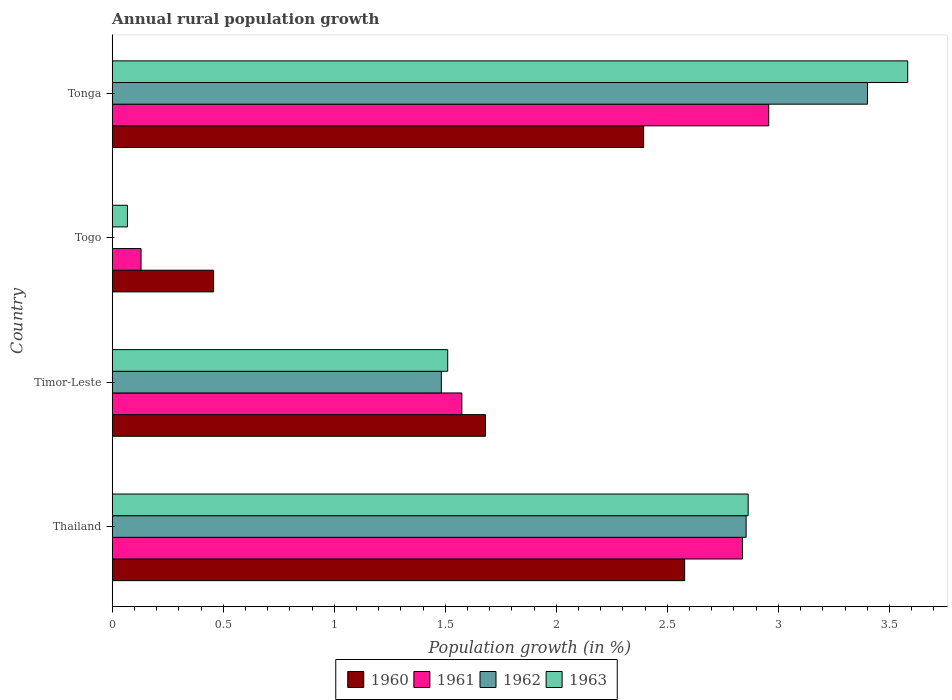How many groups of bars are there?
Your response must be concise. 4. Are the number of bars per tick equal to the number of legend labels?
Give a very brief answer. No. How many bars are there on the 3rd tick from the bottom?
Your answer should be very brief. 3. What is the label of the 4th group of bars from the top?
Keep it short and to the point. Thailand. In how many cases, is the number of bars for a given country not equal to the number of legend labels?
Make the answer very short. 1. What is the percentage of rural population growth in 1961 in Tonga?
Provide a short and direct response. 2.96. Across all countries, what is the maximum percentage of rural population growth in 1960?
Your answer should be compact. 2.58. Across all countries, what is the minimum percentage of rural population growth in 1962?
Give a very brief answer. 0. In which country was the percentage of rural population growth in 1961 maximum?
Provide a short and direct response. Tonga. What is the total percentage of rural population growth in 1961 in the graph?
Ensure brevity in your answer.  7.5. What is the difference between the percentage of rural population growth in 1960 in Thailand and that in Togo?
Keep it short and to the point. 2.12. What is the difference between the percentage of rural population growth in 1961 in Togo and the percentage of rural population growth in 1960 in Timor-Leste?
Give a very brief answer. -1.55. What is the average percentage of rural population growth in 1961 per country?
Your answer should be very brief. 1.87. What is the difference between the percentage of rural population growth in 1960 and percentage of rural population growth in 1963 in Tonga?
Your response must be concise. -1.19. What is the ratio of the percentage of rural population growth in 1960 in Togo to that in Tonga?
Your answer should be very brief. 0.19. Is the percentage of rural population growth in 1960 in Timor-Leste less than that in Tonga?
Make the answer very short. Yes. Is the difference between the percentage of rural population growth in 1960 in Thailand and Tonga greater than the difference between the percentage of rural population growth in 1963 in Thailand and Tonga?
Your answer should be very brief. Yes. What is the difference between the highest and the second highest percentage of rural population growth in 1962?
Offer a very short reply. 0.55. What is the difference between the highest and the lowest percentage of rural population growth in 1961?
Your answer should be very brief. 2.83. Is the sum of the percentage of rural population growth in 1961 in Timor-Leste and Tonga greater than the maximum percentage of rural population growth in 1960 across all countries?
Provide a short and direct response. Yes. Is it the case that in every country, the sum of the percentage of rural population growth in 1960 and percentage of rural population growth in 1962 is greater than the sum of percentage of rural population growth in 1961 and percentage of rural population growth in 1963?
Provide a short and direct response. No. Is it the case that in every country, the sum of the percentage of rural population growth in 1963 and percentage of rural population growth in 1961 is greater than the percentage of rural population growth in 1962?
Your response must be concise. Yes. Are all the bars in the graph horizontal?
Your answer should be very brief. Yes. Where does the legend appear in the graph?
Your answer should be compact. Bottom center. How are the legend labels stacked?
Your response must be concise. Horizontal. What is the title of the graph?
Make the answer very short. Annual rural population growth. What is the label or title of the X-axis?
Your answer should be compact. Population growth (in %). What is the Population growth (in %) in 1960 in Thailand?
Your answer should be very brief. 2.58. What is the Population growth (in %) in 1961 in Thailand?
Offer a terse response. 2.84. What is the Population growth (in %) in 1962 in Thailand?
Keep it short and to the point. 2.85. What is the Population growth (in %) of 1963 in Thailand?
Your answer should be very brief. 2.86. What is the Population growth (in %) of 1960 in Timor-Leste?
Offer a very short reply. 1.68. What is the Population growth (in %) of 1961 in Timor-Leste?
Your answer should be compact. 1.57. What is the Population growth (in %) of 1962 in Timor-Leste?
Your answer should be very brief. 1.48. What is the Population growth (in %) in 1963 in Timor-Leste?
Provide a succinct answer. 1.51. What is the Population growth (in %) in 1960 in Togo?
Keep it short and to the point. 0.46. What is the Population growth (in %) of 1961 in Togo?
Make the answer very short. 0.13. What is the Population growth (in %) of 1963 in Togo?
Offer a terse response. 0.07. What is the Population growth (in %) of 1960 in Tonga?
Offer a very short reply. 2.39. What is the Population growth (in %) in 1961 in Tonga?
Your answer should be compact. 2.96. What is the Population growth (in %) in 1962 in Tonga?
Keep it short and to the point. 3.4. What is the Population growth (in %) of 1963 in Tonga?
Ensure brevity in your answer.  3.58. Across all countries, what is the maximum Population growth (in %) of 1960?
Your answer should be very brief. 2.58. Across all countries, what is the maximum Population growth (in %) in 1961?
Offer a terse response. 2.96. Across all countries, what is the maximum Population growth (in %) of 1962?
Your answer should be very brief. 3.4. Across all countries, what is the maximum Population growth (in %) in 1963?
Keep it short and to the point. 3.58. Across all countries, what is the minimum Population growth (in %) of 1960?
Make the answer very short. 0.46. Across all countries, what is the minimum Population growth (in %) in 1961?
Provide a short and direct response. 0.13. Across all countries, what is the minimum Population growth (in %) in 1962?
Ensure brevity in your answer.  0. Across all countries, what is the minimum Population growth (in %) of 1963?
Make the answer very short. 0.07. What is the total Population growth (in %) of 1960 in the graph?
Offer a terse response. 7.11. What is the total Population growth (in %) in 1961 in the graph?
Offer a very short reply. 7.5. What is the total Population growth (in %) in 1962 in the graph?
Give a very brief answer. 7.74. What is the total Population growth (in %) in 1963 in the graph?
Provide a succinct answer. 8.03. What is the difference between the Population growth (in %) of 1960 in Thailand and that in Timor-Leste?
Provide a short and direct response. 0.9. What is the difference between the Population growth (in %) in 1961 in Thailand and that in Timor-Leste?
Offer a very short reply. 1.26. What is the difference between the Population growth (in %) in 1962 in Thailand and that in Timor-Leste?
Offer a very short reply. 1.37. What is the difference between the Population growth (in %) in 1963 in Thailand and that in Timor-Leste?
Make the answer very short. 1.35. What is the difference between the Population growth (in %) of 1960 in Thailand and that in Togo?
Give a very brief answer. 2.12. What is the difference between the Population growth (in %) of 1961 in Thailand and that in Togo?
Offer a very short reply. 2.71. What is the difference between the Population growth (in %) of 1963 in Thailand and that in Togo?
Your answer should be very brief. 2.8. What is the difference between the Population growth (in %) of 1960 in Thailand and that in Tonga?
Provide a succinct answer. 0.18. What is the difference between the Population growth (in %) in 1961 in Thailand and that in Tonga?
Provide a short and direct response. -0.12. What is the difference between the Population growth (in %) in 1962 in Thailand and that in Tonga?
Your answer should be very brief. -0.55. What is the difference between the Population growth (in %) of 1963 in Thailand and that in Tonga?
Keep it short and to the point. -0.72. What is the difference between the Population growth (in %) of 1960 in Timor-Leste and that in Togo?
Make the answer very short. 1.22. What is the difference between the Population growth (in %) in 1961 in Timor-Leste and that in Togo?
Your answer should be compact. 1.44. What is the difference between the Population growth (in %) of 1963 in Timor-Leste and that in Togo?
Give a very brief answer. 1.44. What is the difference between the Population growth (in %) in 1960 in Timor-Leste and that in Tonga?
Ensure brevity in your answer.  -0.71. What is the difference between the Population growth (in %) of 1961 in Timor-Leste and that in Tonga?
Provide a short and direct response. -1.38. What is the difference between the Population growth (in %) of 1962 in Timor-Leste and that in Tonga?
Provide a short and direct response. -1.92. What is the difference between the Population growth (in %) in 1963 in Timor-Leste and that in Tonga?
Provide a short and direct response. -2.07. What is the difference between the Population growth (in %) of 1960 in Togo and that in Tonga?
Keep it short and to the point. -1.94. What is the difference between the Population growth (in %) in 1961 in Togo and that in Tonga?
Give a very brief answer. -2.83. What is the difference between the Population growth (in %) in 1963 in Togo and that in Tonga?
Give a very brief answer. -3.51. What is the difference between the Population growth (in %) of 1960 in Thailand and the Population growth (in %) of 1961 in Timor-Leste?
Ensure brevity in your answer.  1. What is the difference between the Population growth (in %) of 1960 in Thailand and the Population growth (in %) of 1962 in Timor-Leste?
Your answer should be very brief. 1.1. What is the difference between the Population growth (in %) of 1960 in Thailand and the Population growth (in %) of 1963 in Timor-Leste?
Provide a short and direct response. 1.07. What is the difference between the Population growth (in %) of 1961 in Thailand and the Population growth (in %) of 1962 in Timor-Leste?
Keep it short and to the point. 1.36. What is the difference between the Population growth (in %) of 1961 in Thailand and the Population growth (in %) of 1963 in Timor-Leste?
Offer a terse response. 1.33. What is the difference between the Population growth (in %) in 1962 in Thailand and the Population growth (in %) in 1963 in Timor-Leste?
Make the answer very short. 1.34. What is the difference between the Population growth (in %) in 1960 in Thailand and the Population growth (in %) in 1961 in Togo?
Offer a terse response. 2.45. What is the difference between the Population growth (in %) of 1960 in Thailand and the Population growth (in %) of 1963 in Togo?
Make the answer very short. 2.51. What is the difference between the Population growth (in %) of 1961 in Thailand and the Population growth (in %) of 1963 in Togo?
Keep it short and to the point. 2.77. What is the difference between the Population growth (in %) of 1962 in Thailand and the Population growth (in %) of 1963 in Togo?
Give a very brief answer. 2.79. What is the difference between the Population growth (in %) of 1960 in Thailand and the Population growth (in %) of 1961 in Tonga?
Your answer should be very brief. -0.38. What is the difference between the Population growth (in %) in 1960 in Thailand and the Population growth (in %) in 1962 in Tonga?
Offer a terse response. -0.82. What is the difference between the Population growth (in %) in 1960 in Thailand and the Population growth (in %) in 1963 in Tonga?
Keep it short and to the point. -1. What is the difference between the Population growth (in %) in 1961 in Thailand and the Population growth (in %) in 1962 in Tonga?
Offer a very short reply. -0.56. What is the difference between the Population growth (in %) in 1961 in Thailand and the Population growth (in %) in 1963 in Tonga?
Your response must be concise. -0.74. What is the difference between the Population growth (in %) in 1962 in Thailand and the Population growth (in %) in 1963 in Tonga?
Offer a terse response. -0.73. What is the difference between the Population growth (in %) in 1960 in Timor-Leste and the Population growth (in %) in 1961 in Togo?
Make the answer very short. 1.55. What is the difference between the Population growth (in %) of 1960 in Timor-Leste and the Population growth (in %) of 1963 in Togo?
Give a very brief answer. 1.61. What is the difference between the Population growth (in %) in 1961 in Timor-Leste and the Population growth (in %) in 1963 in Togo?
Your response must be concise. 1.51. What is the difference between the Population growth (in %) of 1962 in Timor-Leste and the Population growth (in %) of 1963 in Togo?
Your answer should be very brief. 1.41. What is the difference between the Population growth (in %) of 1960 in Timor-Leste and the Population growth (in %) of 1961 in Tonga?
Provide a short and direct response. -1.28. What is the difference between the Population growth (in %) of 1960 in Timor-Leste and the Population growth (in %) of 1962 in Tonga?
Offer a very short reply. -1.72. What is the difference between the Population growth (in %) of 1960 in Timor-Leste and the Population growth (in %) of 1963 in Tonga?
Offer a terse response. -1.9. What is the difference between the Population growth (in %) of 1961 in Timor-Leste and the Population growth (in %) of 1962 in Tonga?
Keep it short and to the point. -1.83. What is the difference between the Population growth (in %) in 1961 in Timor-Leste and the Population growth (in %) in 1963 in Tonga?
Ensure brevity in your answer.  -2.01. What is the difference between the Population growth (in %) of 1962 in Timor-Leste and the Population growth (in %) of 1963 in Tonga?
Your response must be concise. -2.1. What is the difference between the Population growth (in %) of 1960 in Togo and the Population growth (in %) of 1961 in Tonga?
Keep it short and to the point. -2.5. What is the difference between the Population growth (in %) of 1960 in Togo and the Population growth (in %) of 1962 in Tonga?
Give a very brief answer. -2.94. What is the difference between the Population growth (in %) of 1960 in Togo and the Population growth (in %) of 1963 in Tonga?
Provide a succinct answer. -3.13. What is the difference between the Population growth (in %) in 1961 in Togo and the Population growth (in %) in 1962 in Tonga?
Provide a succinct answer. -3.27. What is the difference between the Population growth (in %) of 1961 in Togo and the Population growth (in %) of 1963 in Tonga?
Provide a succinct answer. -3.45. What is the average Population growth (in %) of 1960 per country?
Make the answer very short. 1.78. What is the average Population growth (in %) of 1961 per country?
Your answer should be compact. 1.87. What is the average Population growth (in %) in 1962 per country?
Offer a very short reply. 1.93. What is the average Population growth (in %) of 1963 per country?
Your response must be concise. 2.01. What is the difference between the Population growth (in %) of 1960 and Population growth (in %) of 1961 in Thailand?
Offer a very short reply. -0.26. What is the difference between the Population growth (in %) of 1960 and Population growth (in %) of 1962 in Thailand?
Provide a short and direct response. -0.28. What is the difference between the Population growth (in %) of 1960 and Population growth (in %) of 1963 in Thailand?
Your answer should be very brief. -0.29. What is the difference between the Population growth (in %) in 1961 and Population growth (in %) in 1962 in Thailand?
Provide a succinct answer. -0.02. What is the difference between the Population growth (in %) in 1961 and Population growth (in %) in 1963 in Thailand?
Keep it short and to the point. -0.03. What is the difference between the Population growth (in %) in 1962 and Population growth (in %) in 1963 in Thailand?
Give a very brief answer. -0.01. What is the difference between the Population growth (in %) in 1960 and Population growth (in %) in 1961 in Timor-Leste?
Your answer should be very brief. 0.11. What is the difference between the Population growth (in %) of 1960 and Population growth (in %) of 1962 in Timor-Leste?
Make the answer very short. 0.2. What is the difference between the Population growth (in %) in 1960 and Population growth (in %) in 1963 in Timor-Leste?
Your answer should be compact. 0.17. What is the difference between the Population growth (in %) of 1961 and Population growth (in %) of 1962 in Timor-Leste?
Ensure brevity in your answer.  0.09. What is the difference between the Population growth (in %) of 1961 and Population growth (in %) of 1963 in Timor-Leste?
Provide a short and direct response. 0.06. What is the difference between the Population growth (in %) of 1962 and Population growth (in %) of 1963 in Timor-Leste?
Offer a very short reply. -0.03. What is the difference between the Population growth (in %) in 1960 and Population growth (in %) in 1961 in Togo?
Provide a short and direct response. 0.33. What is the difference between the Population growth (in %) in 1960 and Population growth (in %) in 1963 in Togo?
Make the answer very short. 0.39. What is the difference between the Population growth (in %) in 1961 and Population growth (in %) in 1963 in Togo?
Offer a very short reply. 0.06. What is the difference between the Population growth (in %) of 1960 and Population growth (in %) of 1961 in Tonga?
Keep it short and to the point. -0.56. What is the difference between the Population growth (in %) in 1960 and Population growth (in %) in 1962 in Tonga?
Offer a very short reply. -1.01. What is the difference between the Population growth (in %) of 1960 and Population growth (in %) of 1963 in Tonga?
Your answer should be very brief. -1.19. What is the difference between the Population growth (in %) in 1961 and Population growth (in %) in 1962 in Tonga?
Ensure brevity in your answer.  -0.44. What is the difference between the Population growth (in %) of 1961 and Population growth (in %) of 1963 in Tonga?
Provide a short and direct response. -0.63. What is the difference between the Population growth (in %) of 1962 and Population growth (in %) of 1963 in Tonga?
Provide a succinct answer. -0.18. What is the ratio of the Population growth (in %) of 1960 in Thailand to that in Timor-Leste?
Your answer should be compact. 1.53. What is the ratio of the Population growth (in %) in 1961 in Thailand to that in Timor-Leste?
Offer a very short reply. 1.8. What is the ratio of the Population growth (in %) of 1962 in Thailand to that in Timor-Leste?
Offer a very short reply. 1.93. What is the ratio of the Population growth (in %) in 1963 in Thailand to that in Timor-Leste?
Provide a succinct answer. 1.9. What is the ratio of the Population growth (in %) of 1960 in Thailand to that in Togo?
Offer a very short reply. 5.65. What is the ratio of the Population growth (in %) of 1961 in Thailand to that in Togo?
Keep it short and to the point. 21.87. What is the ratio of the Population growth (in %) in 1963 in Thailand to that in Togo?
Your answer should be very brief. 41.77. What is the ratio of the Population growth (in %) in 1960 in Thailand to that in Tonga?
Ensure brevity in your answer.  1.08. What is the ratio of the Population growth (in %) of 1961 in Thailand to that in Tonga?
Provide a short and direct response. 0.96. What is the ratio of the Population growth (in %) of 1962 in Thailand to that in Tonga?
Ensure brevity in your answer.  0.84. What is the ratio of the Population growth (in %) of 1963 in Thailand to that in Tonga?
Provide a succinct answer. 0.8. What is the ratio of the Population growth (in %) of 1960 in Timor-Leste to that in Togo?
Offer a terse response. 3.68. What is the ratio of the Population growth (in %) in 1961 in Timor-Leste to that in Togo?
Your answer should be very brief. 12.13. What is the ratio of the Population growth (in %) of 1963 in Timor-Leste to that in Togo?
Keep it short and to the point. 22.04. What is the ratio of the Population growth (in %) in 1960 in Timor-Leste to that in Tonga?
Ensure brevity in your answer.  0.7. What is the ratio of the Population growth (in %) of 1961 in Timor-Leste to that in Tonga?
Make the answer very short. 0.53. What is the ratio of the Population growth (in %) of 1962 in Timor-Leste to that in Tonga?
Offer a very short reply. 0.44. What is the ratio of the Population growth (in %) in 1963 in Timor-Leste to that in Tonga?
Ensure brevity in your answer.  0.42. What is the ratio of the Population growth (in %) of 1960 in Togo to that in Tonga?
Offer a very short reply. 0.19. What is the ratio of the Population growth (in %) of 1961 in Togo to that in Tonga?
Provide a short and direct response. 0.04. What is the ratio of the Population growth (in %) in 1963 in Togo to that in Tonga?
Offer a very short reply. 0.02. What is the difference between the highest and the second highest Population growth (in %) of 1960?
Offer a very short reply. 0.18. What is the difference between the highest and the second highest Population growth (in %) in 1961?
Provide a succinct answer. 0.12. What is the difference between the highest and the second highest Population growth (in %) of 1962?
Offer a terse response. 0.55. What is the difference between the highest and the second highest Population growth (in %) of 1963?
Provide a succinct answer. 0.72. What is the difference between the highest and the lowest Population growth (in %) of 1960?
Make the answer very short. 2.12. What is the difference between the highest and the lowest Population growth (in %) of 1961?
Your answer should be compact. 2.83. What is the difference between the highest and the lowest Population growth (in %) of 1962?
Make the answer very short. 3.4. What is the difference between the highest and the lowest Population growth (in %) in 1963?
Your answer should be compact. 3.51. 